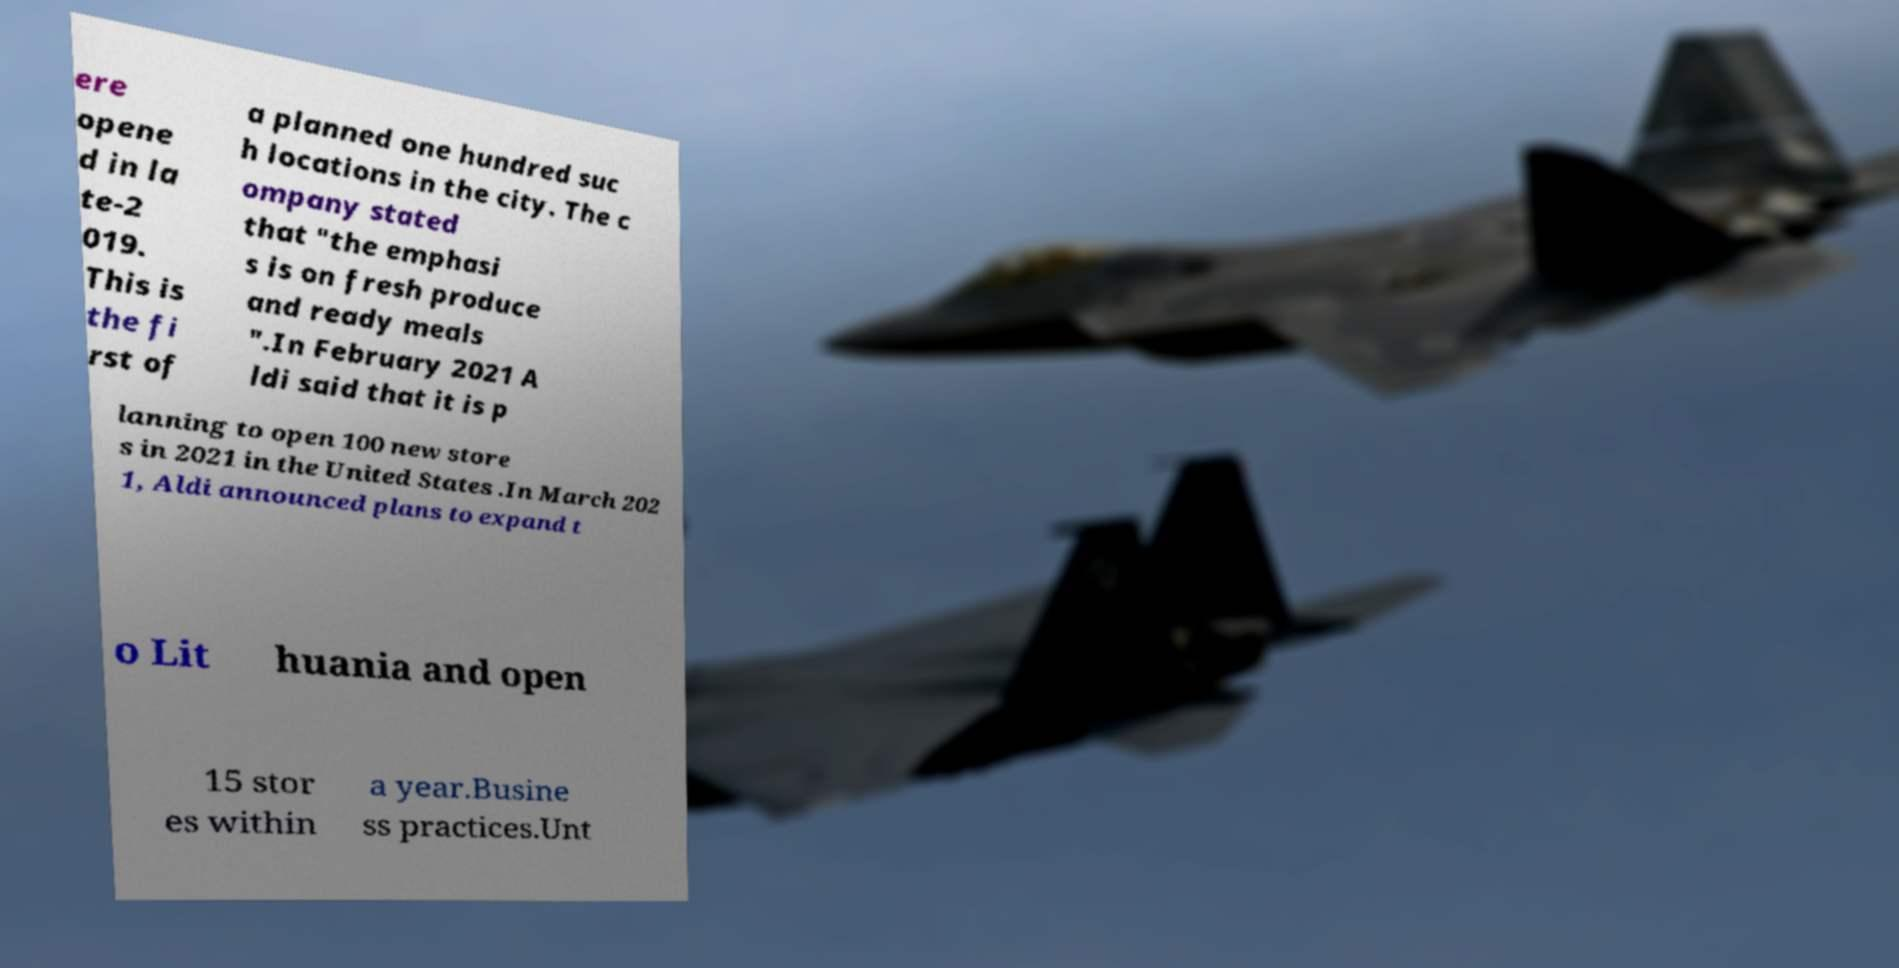I need the written content from this picture converted into text. Can you do that? ere opene d in la te-2 019. This is the fi rst of a planned one hundred suc h locations in the city. The c ompany stated that "the emphasi s is on fresh produce and ready meals ".In February 2021 A ldi said that it is p lanning to open 100 new store s in 2021 in the United States .In March 202 1, Aldi announced plans to expand t o Lit huania and open 15 stor es within a year.Busine ss practices.Unt 